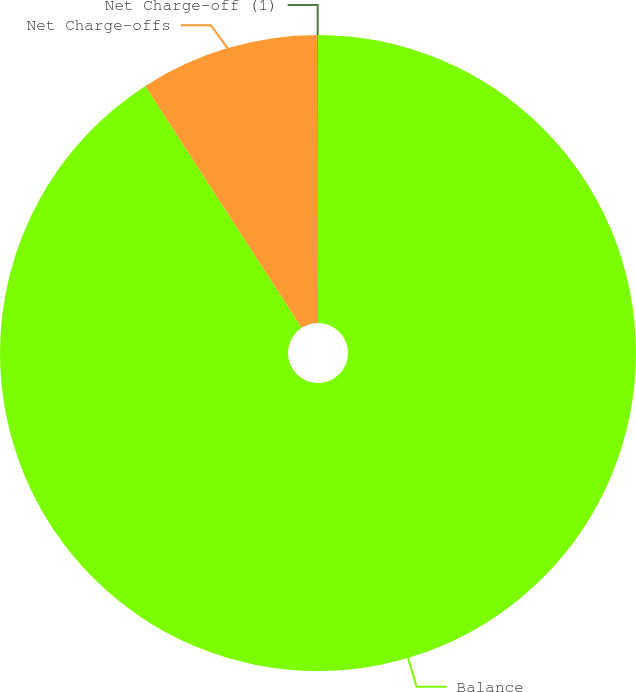Convert chart to OTSL. <chart><loc_0><loc_0><loc_500><loc_500><pie_chart><fcel>Balance<fcel>Net Charge-offs<fcel>Net Charge-off (1)<nl><fcel>90.85%<fcel>9.11%<fcel>0.03%<nl></chart> 